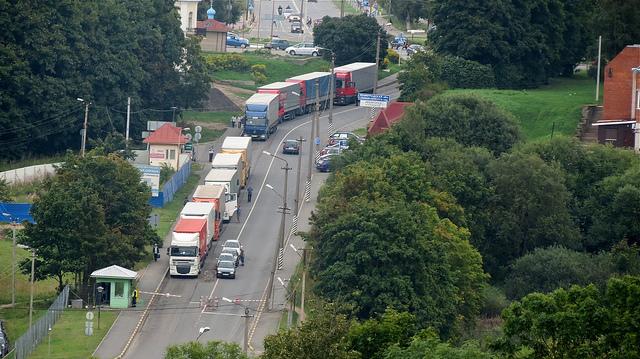Can you see the sky?
Keep it brief. No. Why are the vehicles stopped?
Concise answer only. Checkpoint. What color are the trees?
Write a very short answer. Green. 